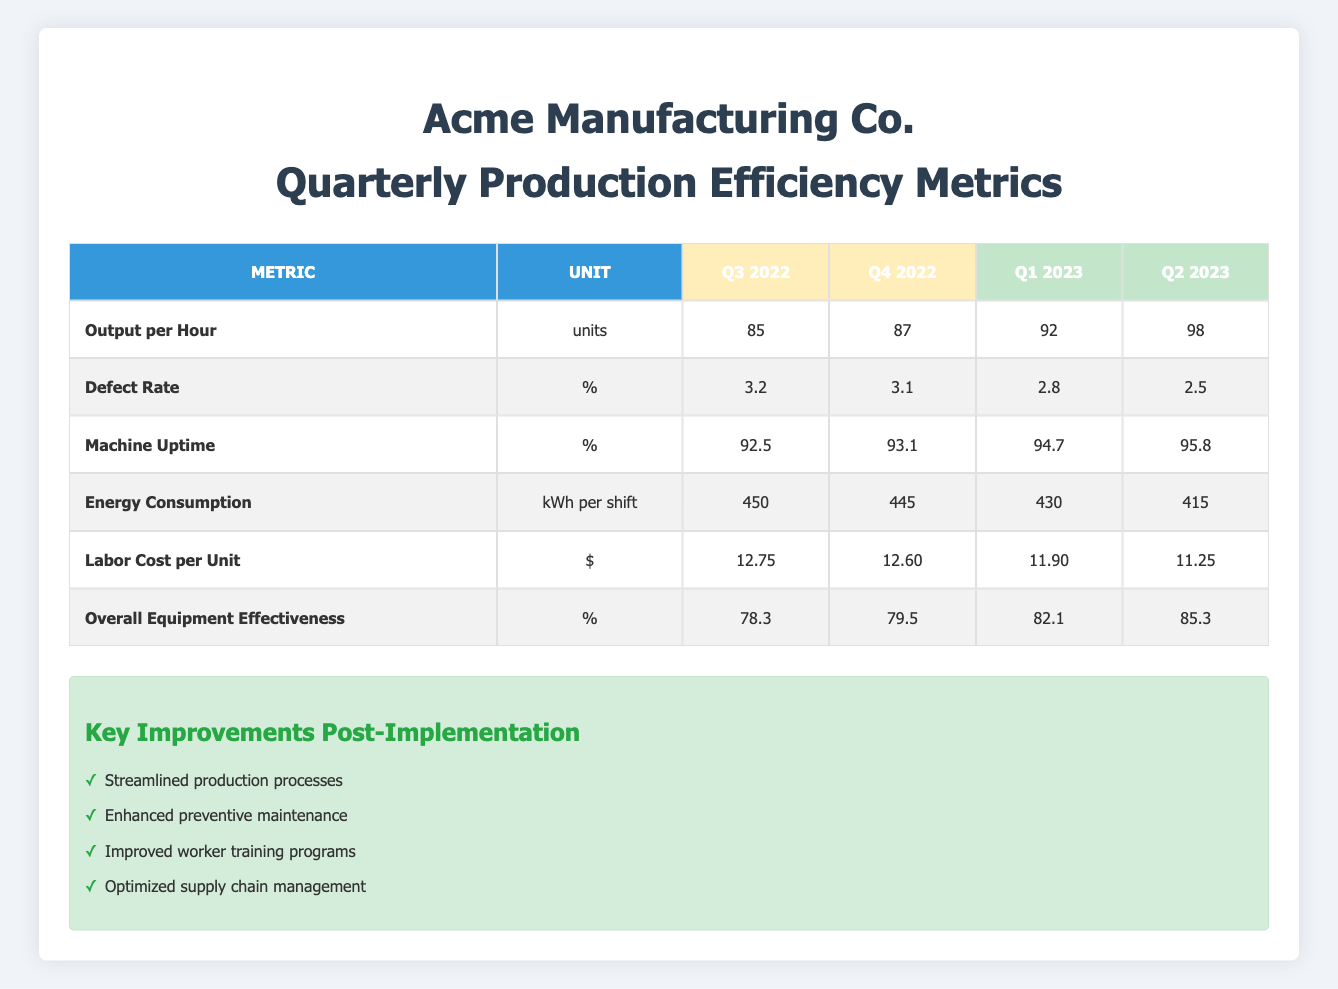What was the output per hour in Q4 2022? The table shows that for the quarter Q4 2022, the output per hour was listed directly under that quarter. Thus, from the table, I can see the value is 87 units.
Answer: 87 What is the defect rate for Q1 2023? Looking at the table, the defect rate for Q1 2023 is directly provided. In this case, the table indicates this value is 2.8%.
Answer: 2.8% Which quarter had the highest machine uptime? The table lists the machine uptime for each quarter. By comparing the values: Q3 2022 (92.5%), Q4 2022 (93.1%), Q1 2023 (94.7%), and Q2 2023 (95.8%), it is clear that Q2 2023 has the highest machine uptime at 95.8%.
Answer: Q2 2023 What is the average labor cost per unit for the pre-implementation quarters? To find the average labor cost per unit for the pre-implementation quarters, I take the two values from Q3 2022 (12.75) and Q4 2022 (12.60). Summing these gives 12.75 + 12.60 = 25.35. Dividing this total by the number of quarters (2) results in an average of 25.35 / 2 = 12.675.
Answer: 12.675 Was there a decrease in energy consumption from Q4 2022 to Q1 2023? In the table, I observe the energy consumption for Q4 2022 is 445 kWh per shift and for Q1 2023 is 430 kWh per shift. Since 430 is less than 445, this indicates a decrease in energy consumption.
Answer: Yes How much did the overall equipment effectiveness increase from Q3 2022 to Q2 2023? The overall equipment effectiveness in Q3 2022 is 78.3%, and in Q2 2023 it is 85.3%. To find the increase, I subtract the Q3 2022 value from the Q2 2023 value: 85.3 - 78.3 = 7.0%. This shows an improvement.
Answer: 7.0% What was the machine uptime in Q1 2023? According to the table, the machine uptime for Q1 2023 is listed as 94.7%. Therefore, the answer is directly taken from the table.
Answer: 94.7% Did the defect rate improve from Q4 2022 to Q2 2023? Reviewing the defect rates, I see Q4 2022 had a defect rate of 3.1%, while Q2 2023 had a defect rate of 2.5%. Since 2.5% is lower than 3.1%, this indicates an improvement in the defect rate.
Answer: Yes 